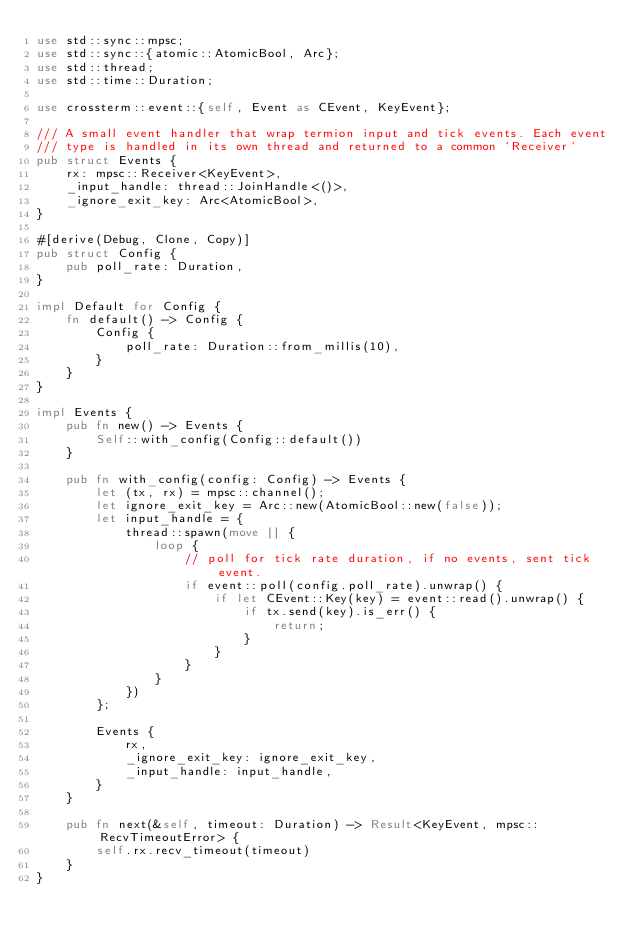Convert code to text. <code><loc_0><loc_0><loc_500><loc_500><_Rust_>use std::sync::mpsc;
use std::sync::{atomic::AtomicBool, Arc};
use std::thread;
use std::time::Duration;

use crossterm::event::{self, Event as CEvent, KeyEvent};

/// A small event handler that wrap termion input and tick events. Each event
/// type is handled in its own thread and returned to a common `Receiver`
pub struct Events {
    rx: mpsc::Receiver<KeyEvent>,
    _input_handle: thread::JoinHandle<()>,
    _ignore_exit_key: Arc<AtomicBool>,
}

#[derive(Debug, Clone, Copy)]
pub struct Config {
    pub poll_rate: Duration,
}

impl Default for Config {
    fn default() -> Config {
        Config {
            poll_rate: Duration::from_millis(10),
        }
    }
}

impl Events {
    pub fn new() -> Events {
        Self::with_config(Config::default())
    }

    pub fn with_config(config: Config) -> Events {
        let (tx, rx) = mpsc::channel();
        let ignore_exit_key = Arc::new(AtomicBool::new(false));
        let input_handle = {
            thread::spawn(move || {
                loop {
                    // poll for tick rate duration, if no events, sent tick event.
                    if event::poll(config.poll_rate).unwrap() {
                        if let CEvent::Key(key) = event::read().unwrap() {
                            if tx.send(key).is_err() {
                                return;
                            }
                        }
                    }
                }
            })
        };

        Events {
            rx,
            _ignore_exit_key: ignore_exit_key,
            _input_handle: input_handle,
        }
    }

    pub fn next(&self, timeout: Duration) -> Result<KeyEvent, mpsc::RecvTimeoutError> {
        self.rx.recv_timeout(timeout)
    }
}
</code> 